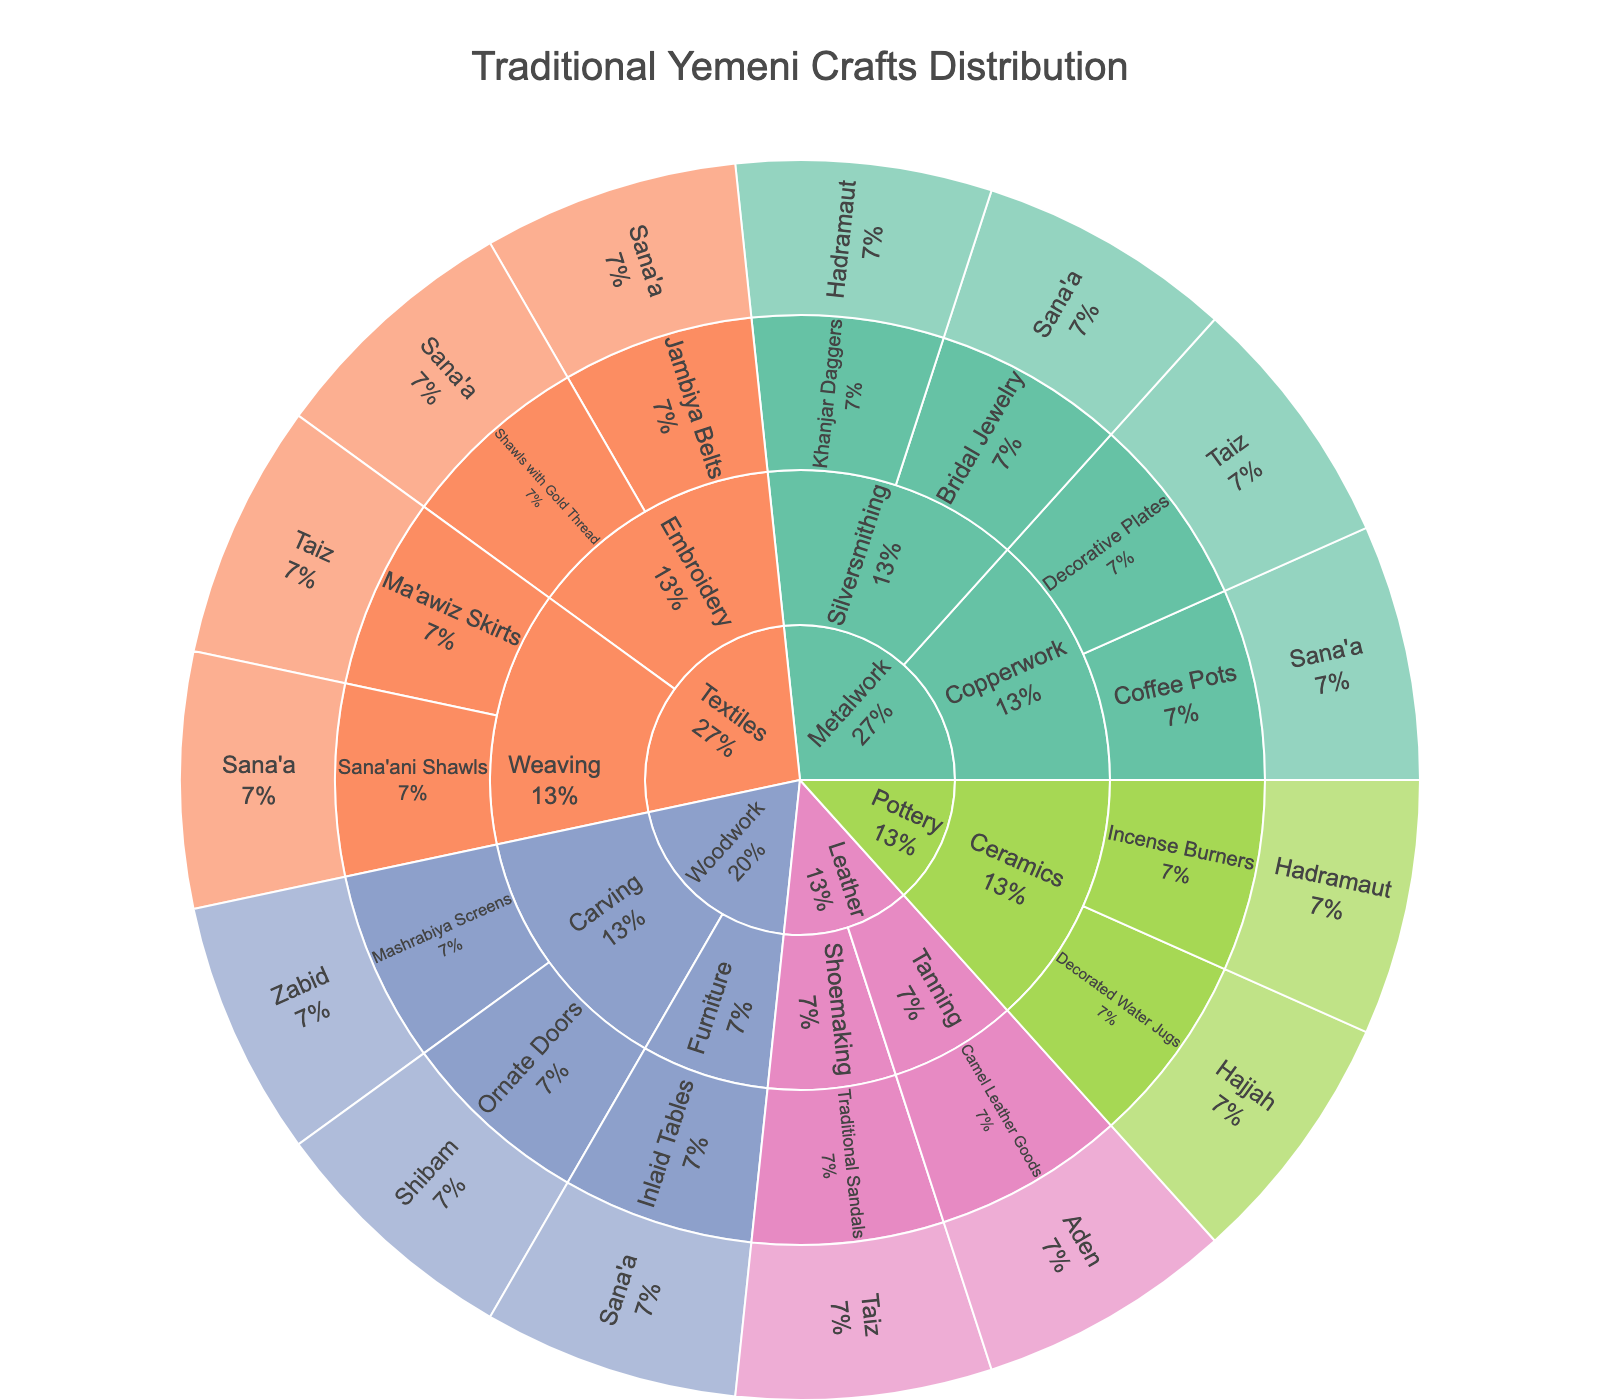What's the title of the plot? The title of the plot is usually found at the top center of the figure.
Answer: Traditional Yemeni Crafts Distribution Which category has the most crafts listed? Scan the outermost layer of the sunburst plot to see which category appears most frequently.
Answer: Textiles How many regions are represented in the plot? Identify and count all distinct regions listed in the innermost layer of the sunburst plot.
Answer: 7 Which craft is unique to Shibam? Find Shibam in the innermost layer, then trace outward to identify the craft associated with it.
Answer: Ornate Doors Compare the number of weaving crafts to embroidery crafts. Which subcategory has more? Count the entries under the weaving subcategory and compare them with those under the embroidery subcategory.
Answer: Weaving What percentage of the crafts are in the Woodwork category? Find the percentage label on the Woodwork segment of the sunburst plot and read it.
Answer: The specific percentage is shown on the plot near Woodwork If you combine the subcategories of Silversmithing and Copperwork, do they have more or fewer crafts than the Weaving subcategory? Count the crafts in Silversmithing and Copperwork, add them together and compare the sum with the count of Weaving crafts.
Answer: Weaving has more Which subcategory within Metalwork has more crafts, Silversmithing or Copperwork? Count the number of entries under Silversmithing and Copperwork subcategories to determine which has more.
Answer: Silversmithing Which category in the plot has the richest regional distribution? Observe the outer layer to see which category spans the most distinct regions.
Answer: Metalwork How many crafts are unique to Sana’a? Navigate through the segments associated with Sana’a and count all unique crafts present.
Answer: 5 